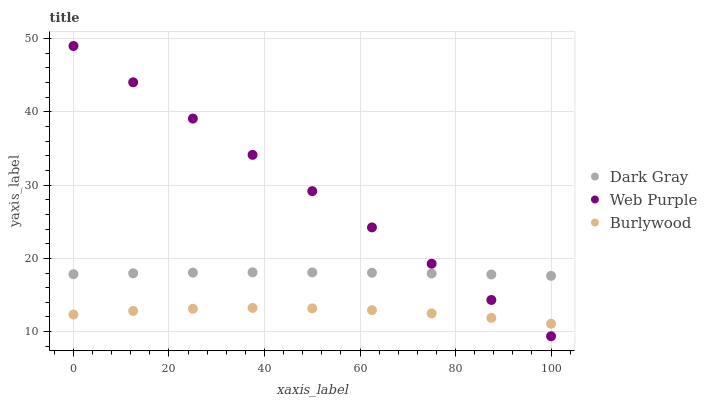Does Burlywood have the minimum area under the curve?
Answer yes or no. Yes. Does Web Purple have the maximum area under the curve?
Answer yes or no. Yes. Does Web Purple have the minimum area under the curve?
Answer yes or no. No. Does Burlywood have the maximum area under the curve?
Answer yes or no. No. Is Web Purple the smoothest?
Answer yes or no. Yes. Is Burlywood the roughest?
Answer yes or no. Yes. Is Burlywood the smoothest?
Answer yes or no. No. Is Web Purple the roughest?
Answer yes or no. No. Does Web Purple have the lowest value?
Answer yes or no. Yes. Does Burlywood have the lowest value?
Answer yes or no. No. Does Web Purple have the highest value?
Answer yes or no. Yes. Does Burlywood have the highest value?
Answer yes or no. No. Is Burlywood less than Dark Gray?
Answer yes or no. Yes. Is Dark Gray greater than Burlywood?
Answer yes or no. Yes. Does Web Purple intersect Burlywood?
Answer yes or no. Yes. Is Web Purple less than Burlywood?
Answer yes or no. No. Is Web Purple greater than Burlywood?
Answer yes or no. No. Does Burlywood intersect Dark Gray?
Answer yes or no. No. 